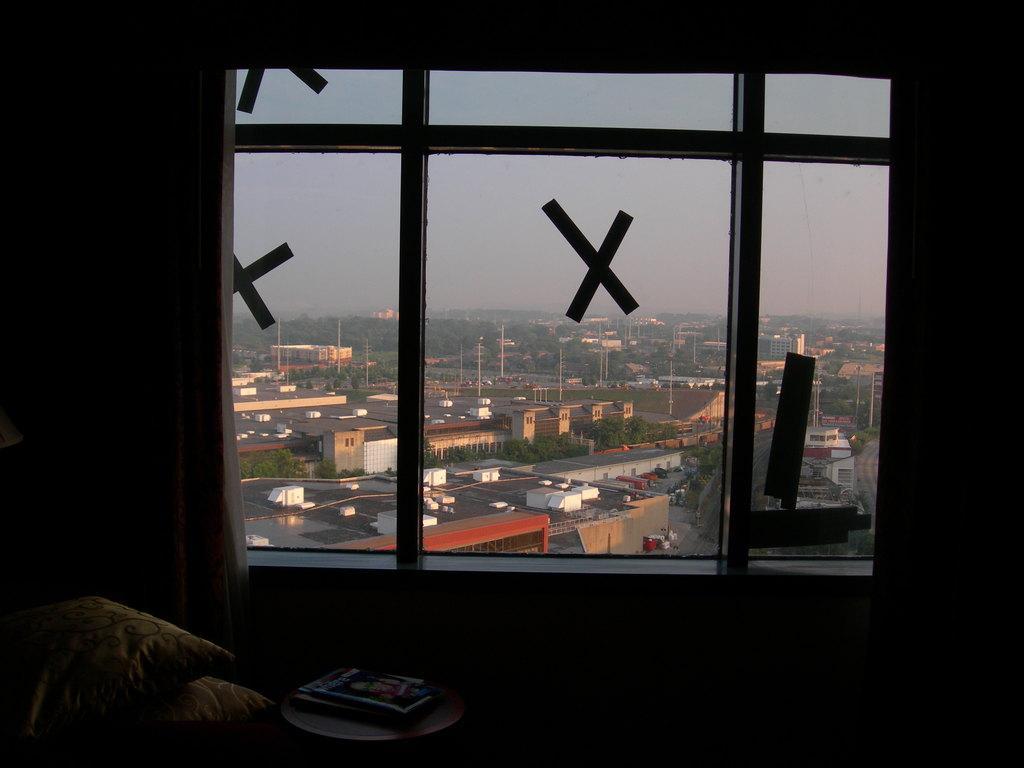Describe this image in one or two sentences. In this image in the front there is a stool. On the stool there are books and on the left side there are pillows. In the center there is a window, behind the window there are poles, trees, buildings. 